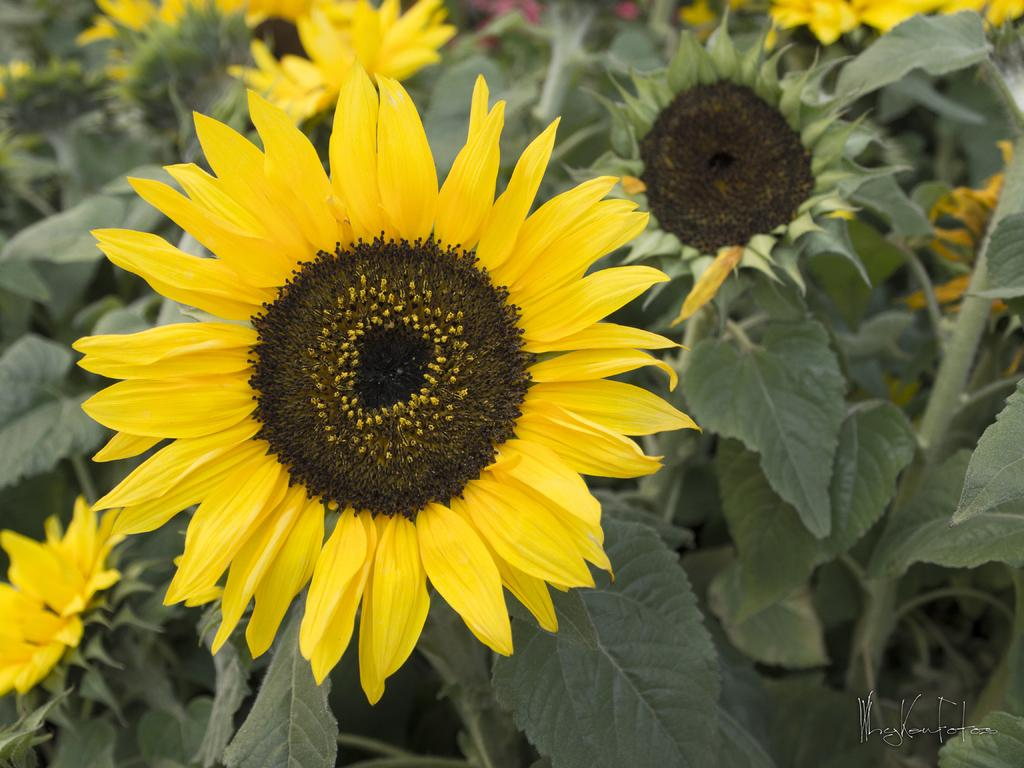What types of living organisms can be seen in the image? Plants and flowers are visible in the image. Where are the plants and flowers located in the image? The plants and flowers are in the center of the image. What color are the plants and flowers in the image? The plants and flowers are yellow in color. What type of stick can be seen holding up the flowers in the image? There is no stick present in the image; the plants and flowers are not supported by any visible structure. 